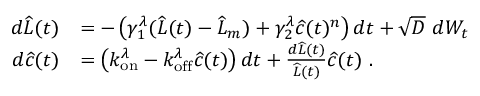<formula> <loc_0><loc_0><loc_500><loc_500>\begin{array} { r l } { d \widehat { L } ( t ) } & { = - \left ( \gamma _ { 1 } ^ { \lambda } ( \widehat { L } ( t ) - \widehat { L } _ { m } ) + \gamma _ { 2 } ^ { \lambda } \widehat { c } ( t ) ^ { n } \right ) d t + \sqrt { D } \ d W _ { t } } \\ { d \widehat { c } ( t ) } & { = \left ( k _ { o n } ^ { \lambda } - k _ { o f f } ^ { \lambda } \widehat { c } ( t ) \right ) d t + \frac { d \widehat { L } ( t ) } { \widehat { L } ( t ) } \widehat { c } ( t ) \ . } \end{array}</formula> 